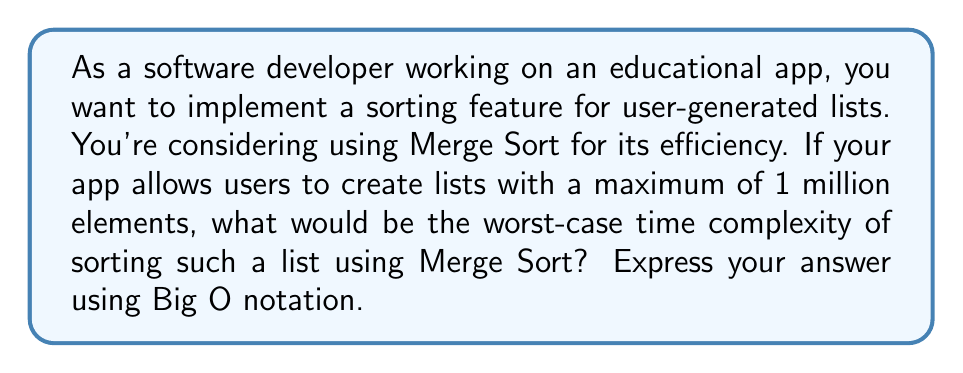Can you solve this math problem? To analyze the time complexity of Merge Sort, we need to understand its algorithm and how it scales with input size:

1. Merge Sort is a divide-and-conquer algorithm that recursively divides the input array into two halves, sorts them, and then merges the sorted halves.

2. The division process continues until we reach subarrays of size 1, which are considered sorted.

3. The number of divisions required to reach subarrays of size 1 is $\log_2 n$, where $n$ is the number of elements in the array.

4. At each level of recursion, we perform a merge operation that takes $O(n)$ time to combine two sorted subarrays.

5. The total number of merge operations at each level is proportional to $n$.

6. Therefore, the overall time complexity can be expressed as $O(n \log n)$.

For the given scenario:
- Maximum number of elements, $n = 1,000,000$

The worst-case time complexity would be:

$$O(n \log n) = O(1,000,000 \log 1,000,000)$$

This can be simplified to $O(n \log n)$, as we're interested in the growth rate rather than the exact number of operations.

It's worth noting that this time complexity holds true for the worst, average, and best cases of Merge Sort, making it a consistent and reliable choice for sorting large datasets in educational applications.
Answer: $O(n \log n)$ 